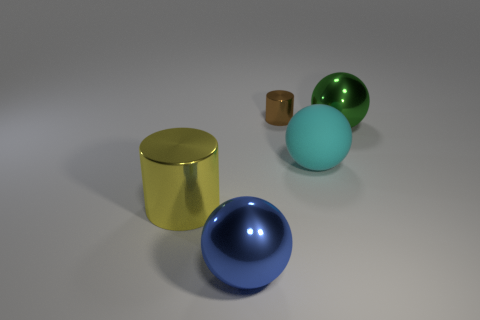Is there a big shiny cylinder that has the same color as the matte thing?
Your response must be concise. No. Are there more large cyan matte spheres that are behind the tiny brown cylinder than gray matte things?
Offer a terse response. No. Does the large cyan matte object have the same shape as the thing that is to the left of the blue object?
Ensure brevity in your answer.  No. Are any small red metallic objects visible?
Your answer should be compact. No. How many small things are either green metal objects or purple matte blocks?
Your answer should be compact. 0. Are there more metal objects on the left side of the small metallic object than large blue metallic spheres that are behind the matte thing?
Your response must be concise. Yes. Is the blue ball made of the same material as the cylinder that is behind the yellow metal cylinder?
Give a very brief answer. Yes. What color is the rubber thing?
Provide a succinct answer. Cyan. There is a large object to the left of the big blue metal sphere; what is its shape?
Make the answer very short. Cylinder. What number of yellow things are big objects or tiny matte blocks?
Your answer should be compact. 1. 